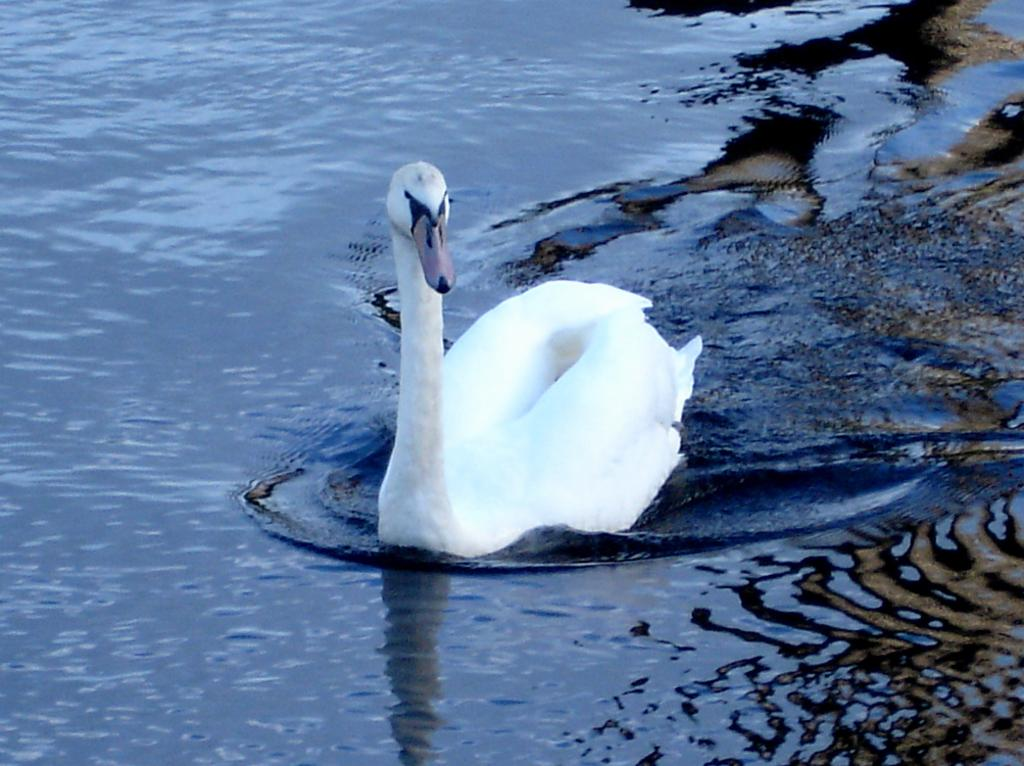What animal is present in the image? There is a duck in the image. Where is the duck located? The duck is on the water. What type of music can be heard playing in the background of the image? There is no music present in the image, as it features a duck on the water. 